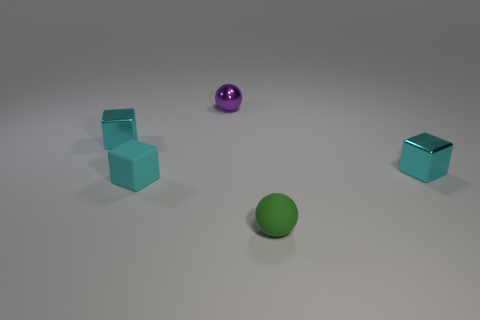Add 1 large gray cubes. How many objects exist? 6 Subtract all balls. How many objects are left? 3 Subtract all small things. Subtract all tiny cylinders. How many objects are left? 0 Add 3 tiny purple balls. How many tiny purple balls are left? 4 Add 4 green spheres. How many green spheres exist? 5 Subtract 0 red balls. How many objects are left? 5 